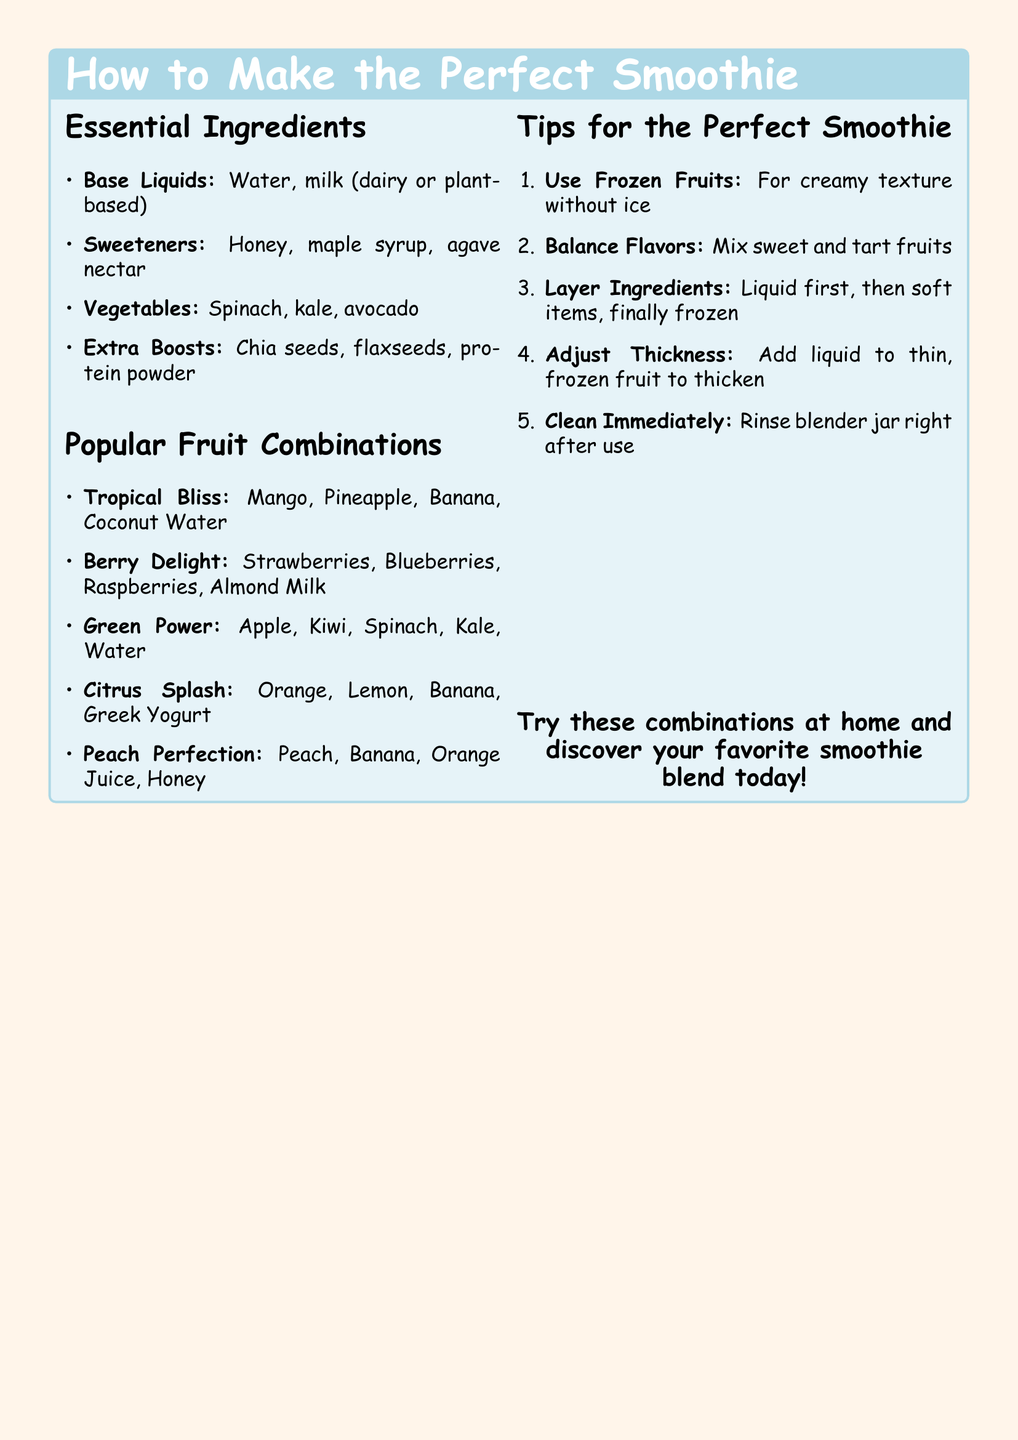What are the base liquids? The base liquids listed in the document are water and milk (dairy or plant-based).
Answer: Water, milk What fruit is included in the Tropical Bliss combination? The Tropical Bliss combination includes mango, pineapple, banana, and coconut water.
Answer: Mango What should you do to achieve a creamy texture? To achieve a creamy texture, the document suggests using frozen fruits.
Answer: Use frozen fruits How many popular fruit combinations are listed? The document lists five popular fruit combinations.
Answer: Five What is the extra boost mentioned for smoothies? The extra boosts instructed include chia seeds, flaxseeds, and protein powder.
Answer: Chia seeds, flaxseeds, protein powder What is the first step suggested for layering ingredients? The first step for layering ingredients indicates to put the liquid first, followed by soft items, and then frozen items last.
Answer: Liquid first What is one way to adjust the thickness of a smoothie? You can adjust the thickness by adding liquid to thin or frozen fruit to thicken.
Answer: Add liquid to thin What is recommended to clean immediately after use? It is recommended to rinse the blender jar immediately after use.
Answer: Blender jar 